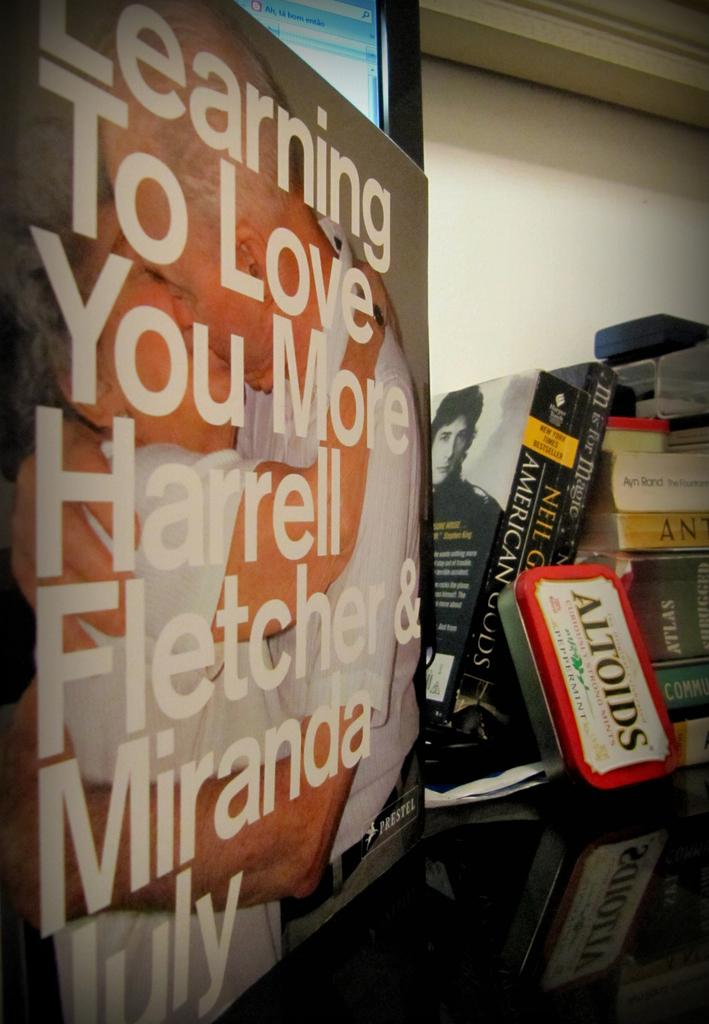<image>
Give a short and clear explanation of the subsequent image. A sign that reads learning to love you more by Harrell Fletcher. 